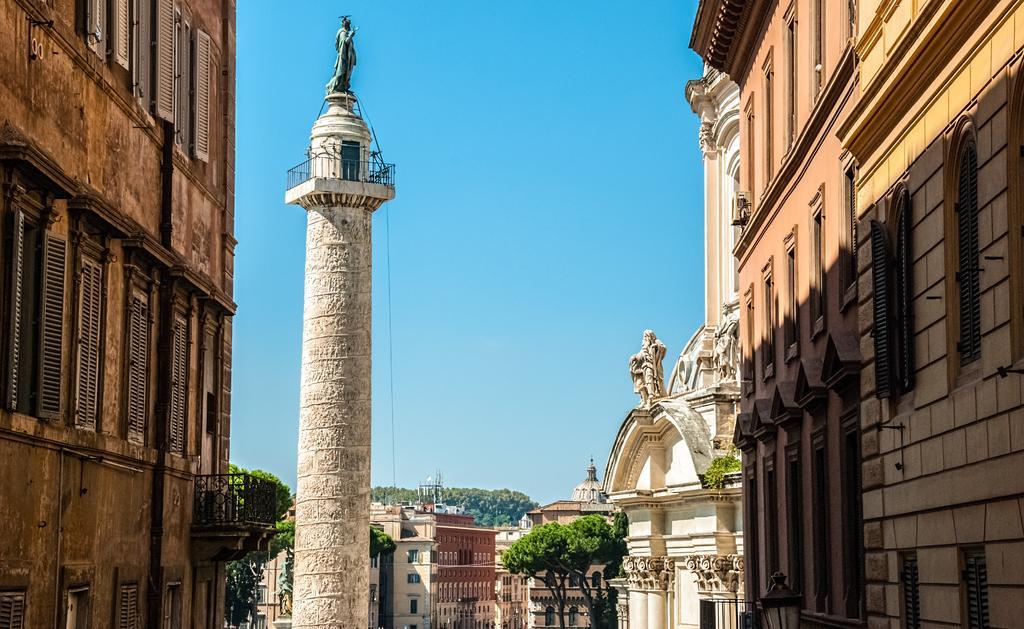In one or two sentences, can you explain what this image depicts? In the foreground of this image, on the other side, there are buildings and a sculpture on a pillar. In the background, there are trees, buildings and the sky. 